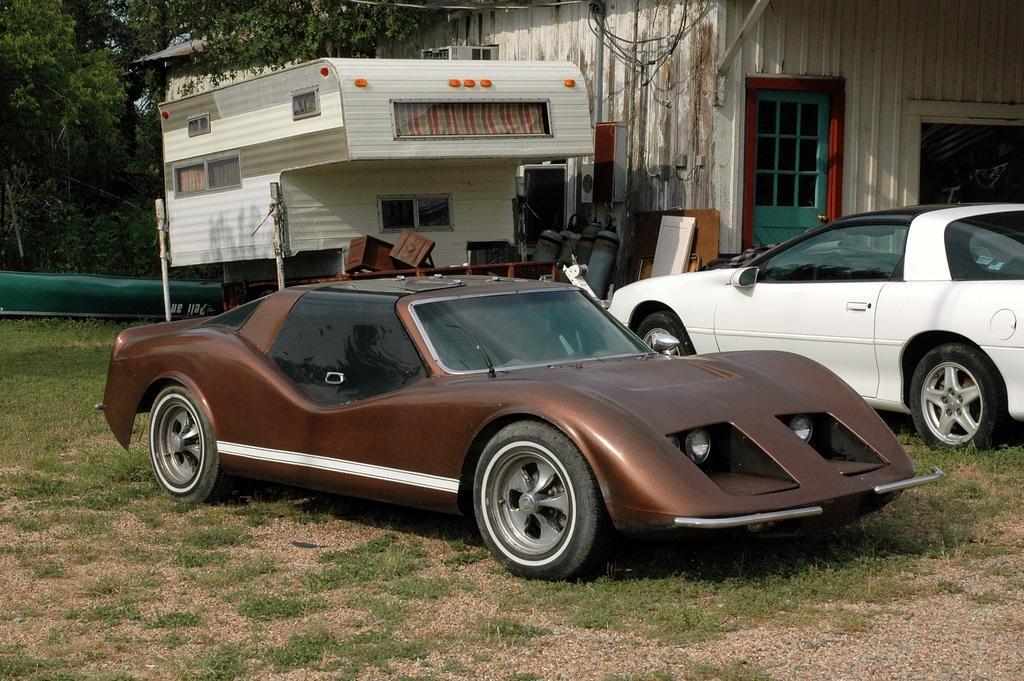Describe this image in one or two sentences. In this picture, we see two cars in brown and white color are parked. At the bottom of the picture, we see the grass and small stones. On the right side, we see a building in white color. Beside that, we see wooden things and a white color thing which looks like a building. There are trees and a green color thing in the background. 